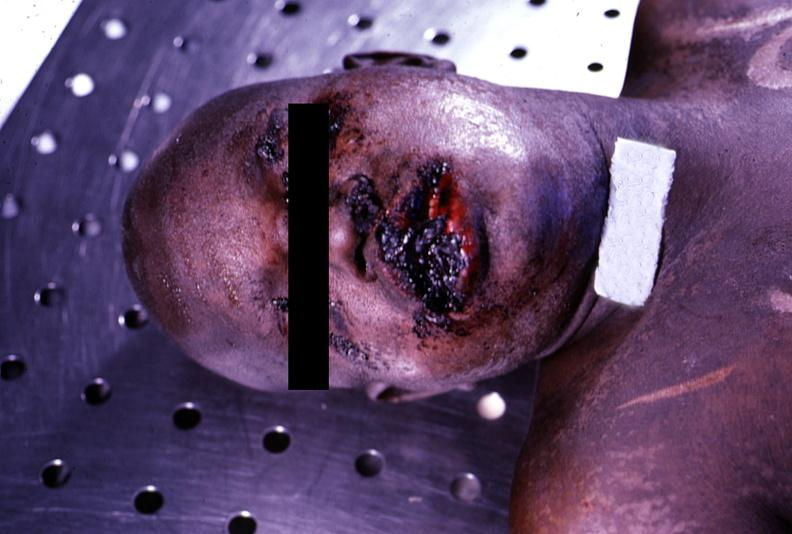does this image show ulcerations, herpes simplex?
Answer the question using a single word or phrase. Yes 